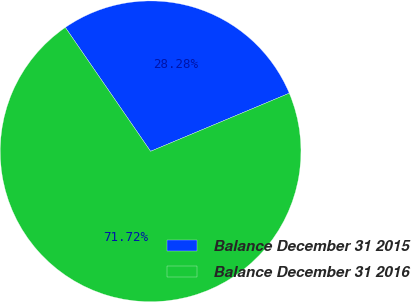Convert chart. <chart><loc_0><loc_0><loc_500><loc_500><pie_chart><fcel>Balance December 31 2015<fcel>Balance December 31 2016<nl><fcel>28.28%<fcel>71.72%<nl></chart> 